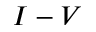<formula> <loc_0><loc_0><loc_500><loc_500>I - V</formula> 